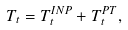Convert formula to latex. <formula><loc_0><loc_0><loc_500><loc_500>T _ { t } = T ^ { I N P } _ { t } + T ^ { P T } _ { t } ,</formula> 